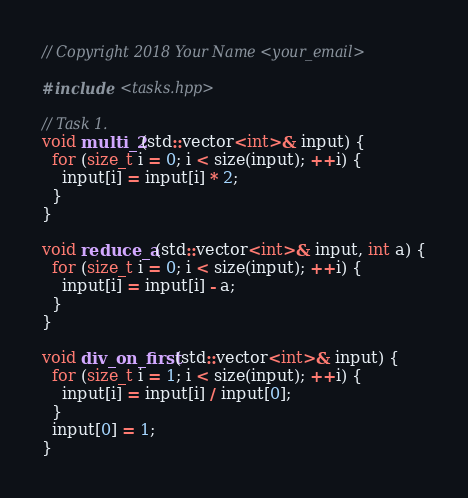<code> <loc_0><loc_0><loc_500><loc_500><_C++_>// Copyright 2018 Your Name <your_email>

#include <tasks.hpp>

// Task 1.
void multi_2(std::vector<int>& input) {
  for (size_t i = 0; i < size(input); ++i) {
    input[i] = input[i] * 2;
  }
}

void reduce_a(std::vector<int>& input, int a) {
  for (size_t i = 0; i < size(input); ++i) {
    input[i] = input[i] - a;
  }
}

void div_on_first(std::vector<int>& input) {
  for (size_t i = 1; i < size(input); ++i) {
    input[i] = input[i] / input[0];
  }
  input[0] = 1;
}
</code> 